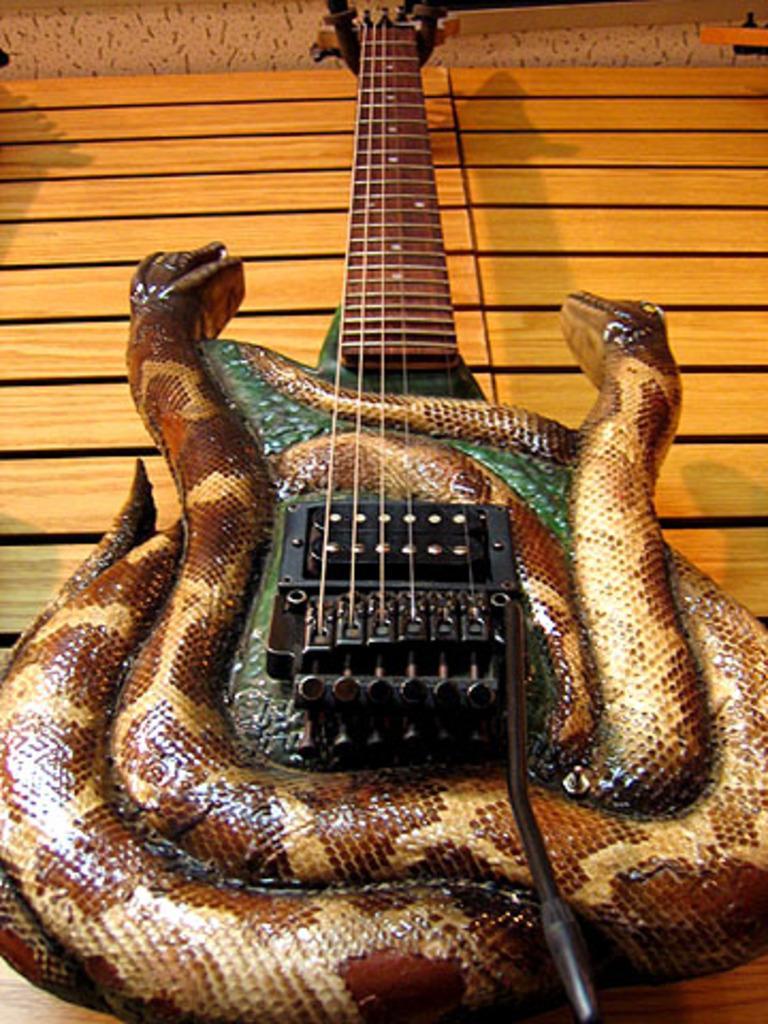Can you describe this image briefly? The picture consists of a guitar which is in the shape of snakes on it, it is placed on the table. 